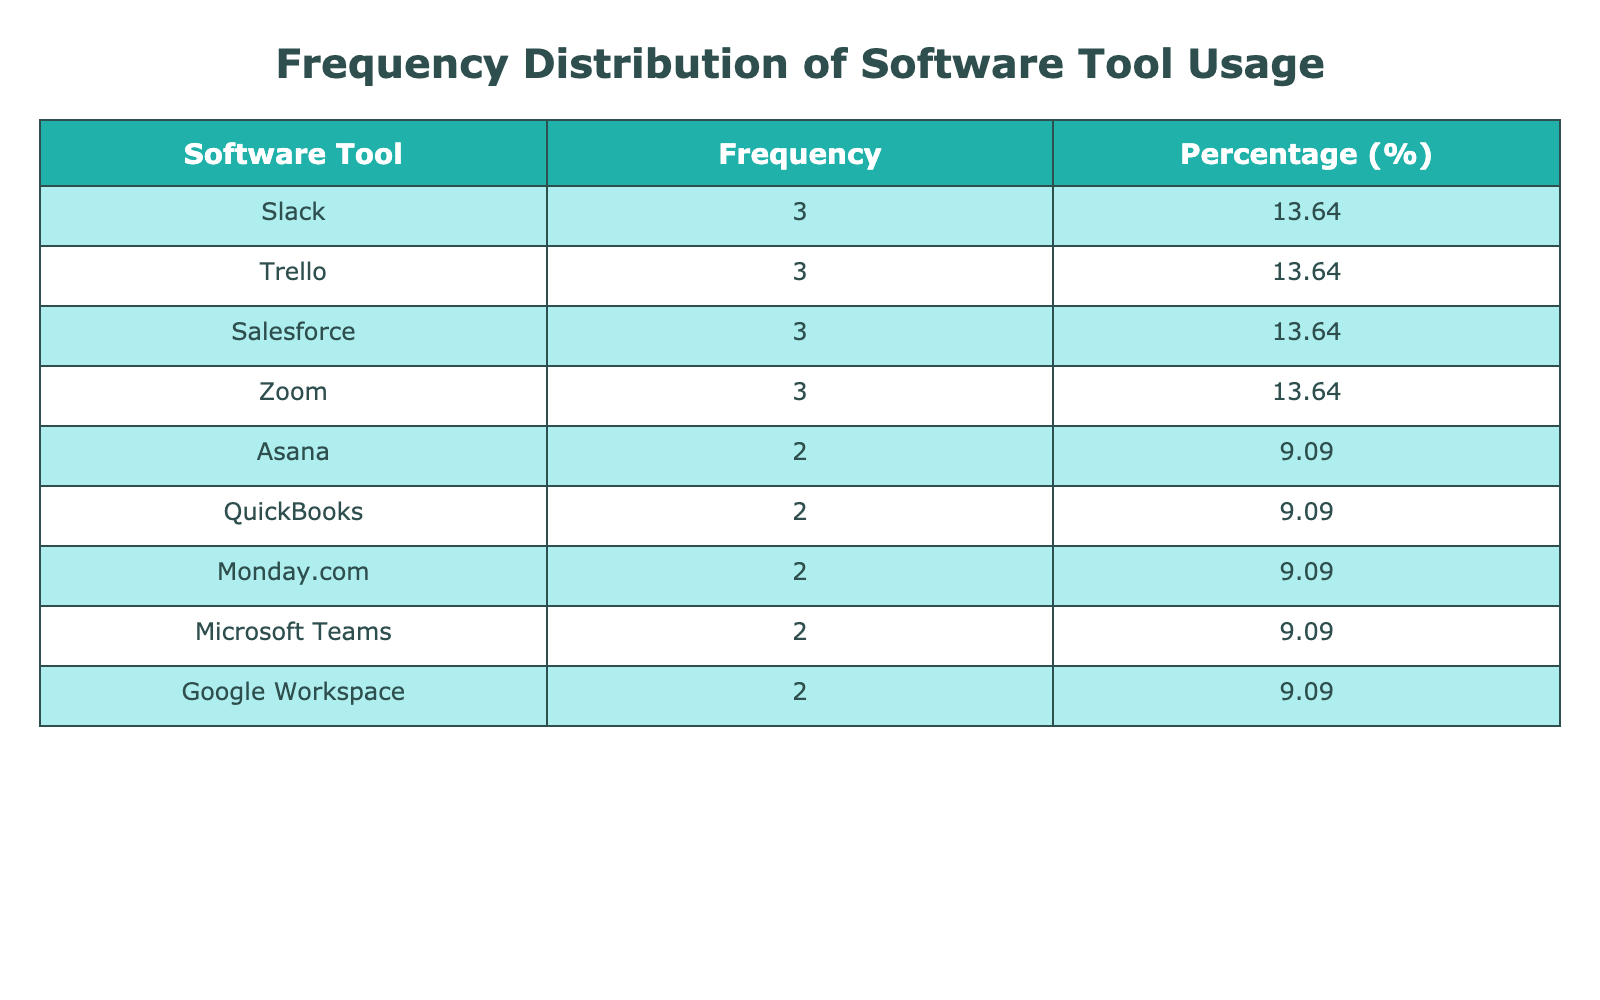What is the software tool with the highest usage frequency? The table lists the frequency of usage for each software tool. By comparing the frequencies, we see that the highest frequency is associated with Salesforce, with a usage frequency of 70.
Answer: Salesforce How many employees used Microsoft Teams? Looking at the table, Microsoft Teams is listed once with a frequency of 75, indicating that one employee used the tool that many times in the quarter.
Answer: 1 What percentage of the total usage does Slack account for? To find the percentage for Slack, we first determine its frequency: Slack has a total frequency of 125 (found by adding the two entries for Slack). Next, we calculate the total frequency of all tools, which is 420. The percentage is (125/420) * 100 = 29.76%.
Answer: 29.76% Which two software tools have the closest usage frequencies? By examining the frequency values, we identify Asana with a frequency of 55 and Zoom with a frequency of 50. The difference is only 5, making them the closest pair of software tools in terms of usage frequency.
Answer: Asana and Zoom Is there any software tool that has a frequency of 10? The table shows that Monday.com has a frequency of 10, confirming that there is indeed a software tool with that frequency.
Answer: Yes What is the total usage frequency for Trello? Trello appears three times in the table (30, 15, 5). Adding these values together gives 30 + 15 + 5 = 50, which is the total frequency for Trello usage across employees.
Answer: 50 Which software tool has the lowest usage frequency? By reviewing the frequency values in the table, Monday.com has the lowest frequency at 10. No other tool has a frequency less than this value.
Answer: Monday.com What is the average frequency of usage for all software tools combined? To find the average usage frequency, we first total the frequencies (420) and divide by the number of unique software tools (8). Thus, the average frequency is 420/8 = 52.5.
Answer: 52.5 How many software tools have a usage frequency greater than 50? The table shows the software tools with frequencies: Salesforce (70), Microsoft Teams (75), Slack (125, summed), and Zoom (65). Thus, there are four tools that exceed a frequency of 50.
Answer: 4 